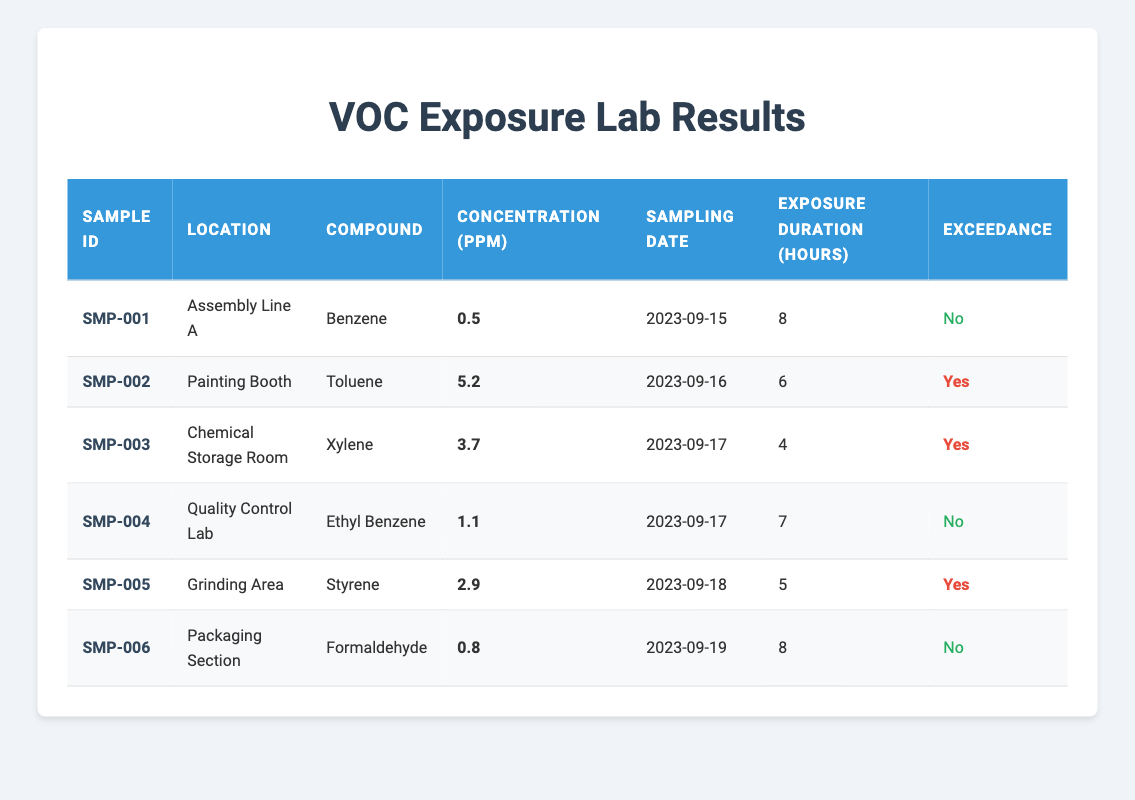What is the concentration of Toluene in the Painting Booth? Referring to the table, under the row for the Painting Booth, the concentration for Toluene is listed as 5.2 ppm.
Answer: 5.2 ppm How many compounds exceed the safe exposure limits? By looking at the table, there are three rows where the exceedance is marked as "Yes." These rows are for Toluene, Xylene, and Styrene. Therefore, the total is three compounds.
Answer: 3 What was the exposure duration for the sample taken in Assembly Line A? The table shows that the exposure duration for the sample collected in Assembly Line A is indicated as 8 hours.
Answer: 8 hours What is the average concentration of all volatile compounds listed in the results? The concentrations provided are 0.5, 5.2, 3.7, 1.1, 2.9, and 0.8 ppm. Summing these values gives 14.2 ppm. There are 6 samples in total, so the average concentration is 14.2/6 = 2.37 ppm.
Answer: 2.37 ppm Did any samples from the Quality Control Lab exceed safe limits? The table indicates that the sample from the Quality Control Lab has an exceedance marked as "No." Therefore, none of the samples from this location exceeded safe limits.
Answer: No In which location was the highest concentration of VOCs measured? The highest concentration in the table is 5.2 ppm for Toluene, located in the Painting Booth. By reviewing all concentrations in the table, this is the maximum value present.
Answer: Painting Booth Which compounds were sampled over a duration of 7 hours or more? Looking at the table, the samples taken in Assembly Line A (8 hours) and the Quality Control Lab (7 hours) specify their exposure durations. The corresponding compounds are Benzene (SMP-001) and Ethyl Benzene (SMP-004).
Answer: Benzene and Ethyl Benzene Were any samples collected from the Grinding Area? Yes, referring to the table, there is a sample listed with the Sample ID SMP-005 taken from the Grinding Area. The exceedance for that sample is marked as "Yes."
Answer: Yes What is the status of exceedance for the sample taken in the Packaging Section? Consulting the table, the exceedance for the sample from the Packaging Section is indicated as "No." Therefore, this tells us that the level measured was within safe limits.
Answer: No 